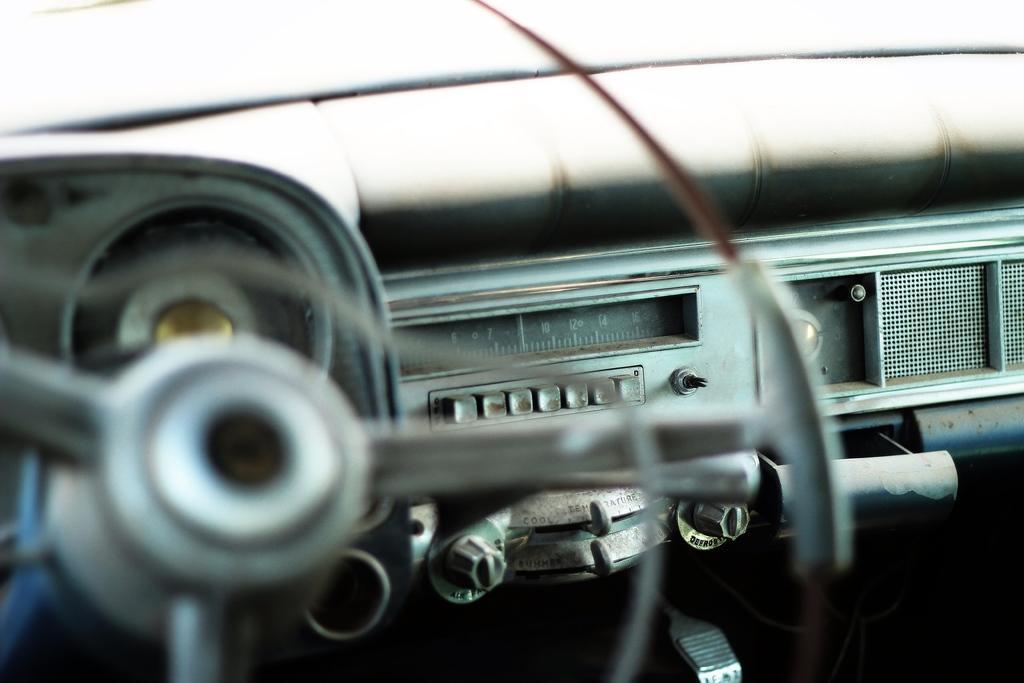Can you describe this image briefly? In this picture we can see a steering, speedometer, buttons and some objects. 